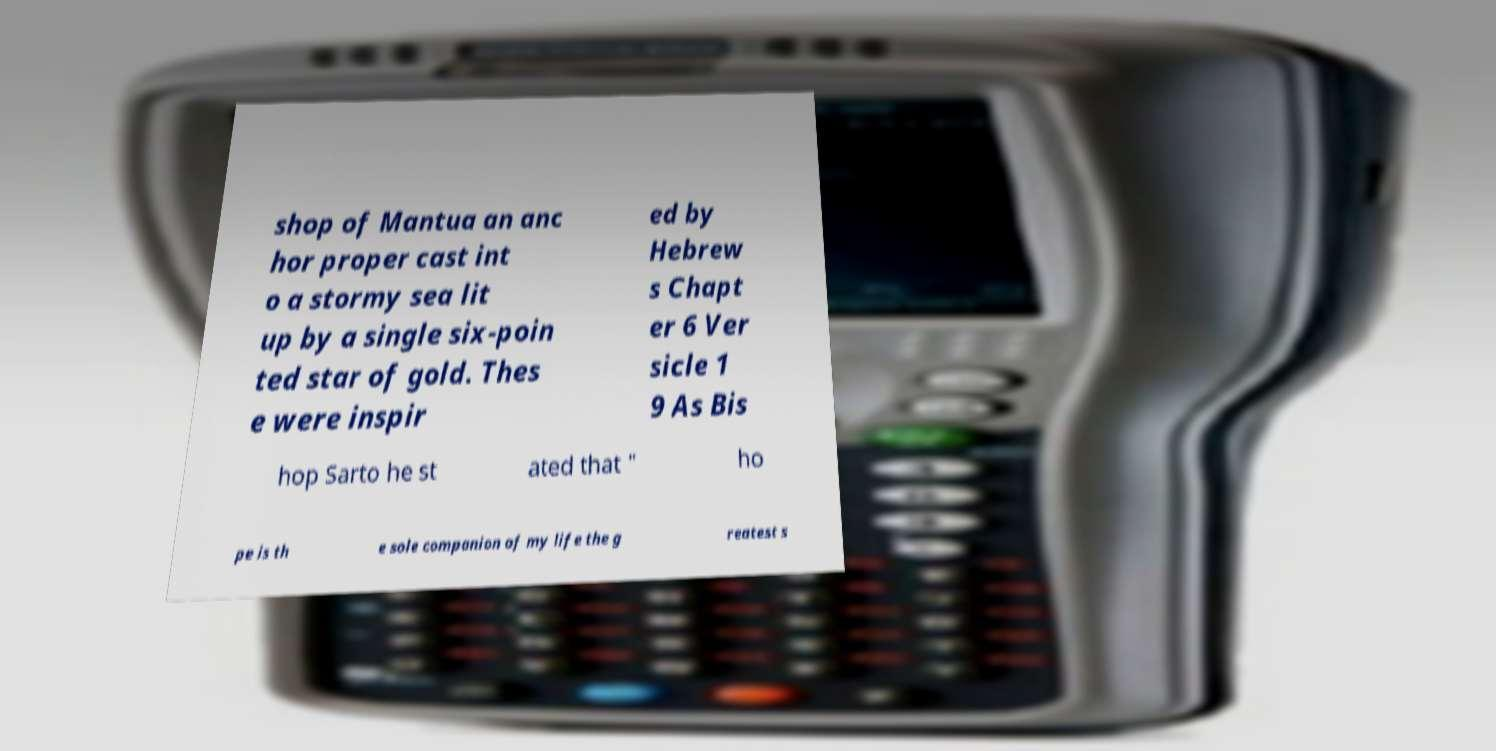What messages or text are displayed in this image? I need them in a readable, typed format. shop of Mantua an anc hor proper cast int o a stormy sea lit up by a single six-poin ted star of gold. Thes e were inspir ed by Hebrew s Chapt er 6 Ver sicle 1 9 As Bis hop Sarto he st ated that " ho pe is th e sole companion of my life the g reatest s 